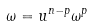Convert formula to latex. <formula><loc_0><loc_0><loc_500><loc_500>\omega = u ^ { n - p } \omega ^ { p }</formula> 